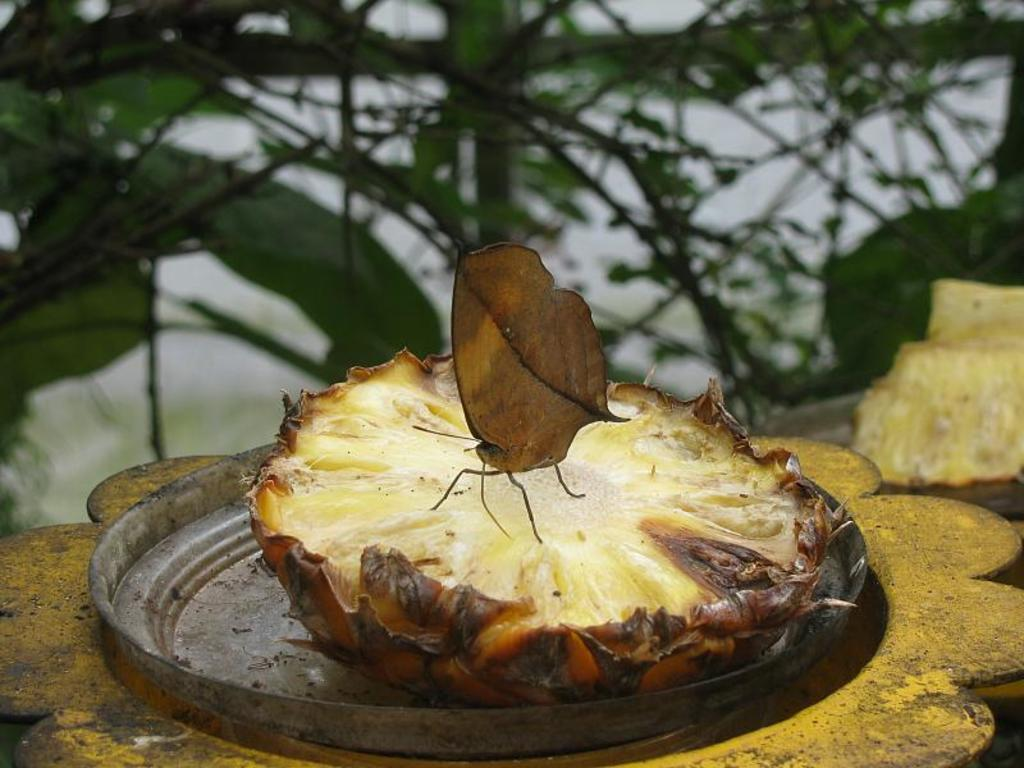What type of insect is present in the image? There is a butterfly in the image. What is the butterfly resting on? The butterfly is on a fruit. What type of leaf is the butterfly using to fly in the image? There is no leaf present in the image, and the butterfly is not using any leaf to fly. 